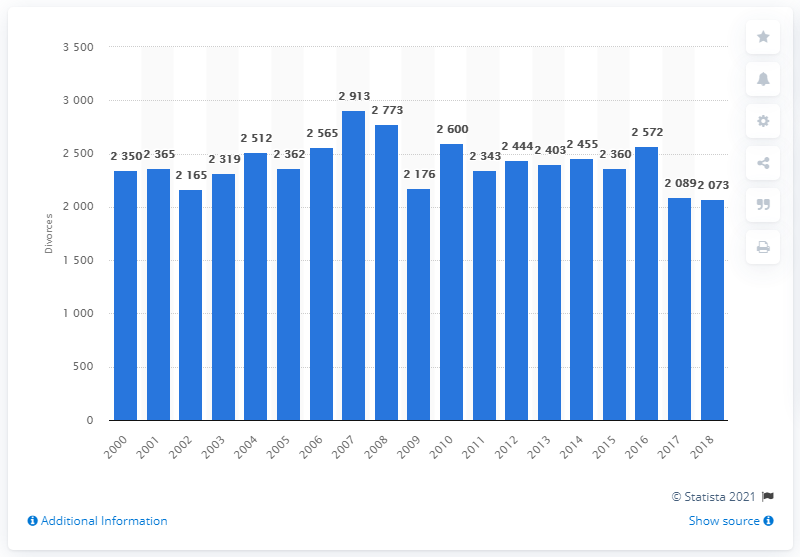Outline some significant characteristics in this image. In 2007, the highest number of divorces was granted in Northern Ireland. 